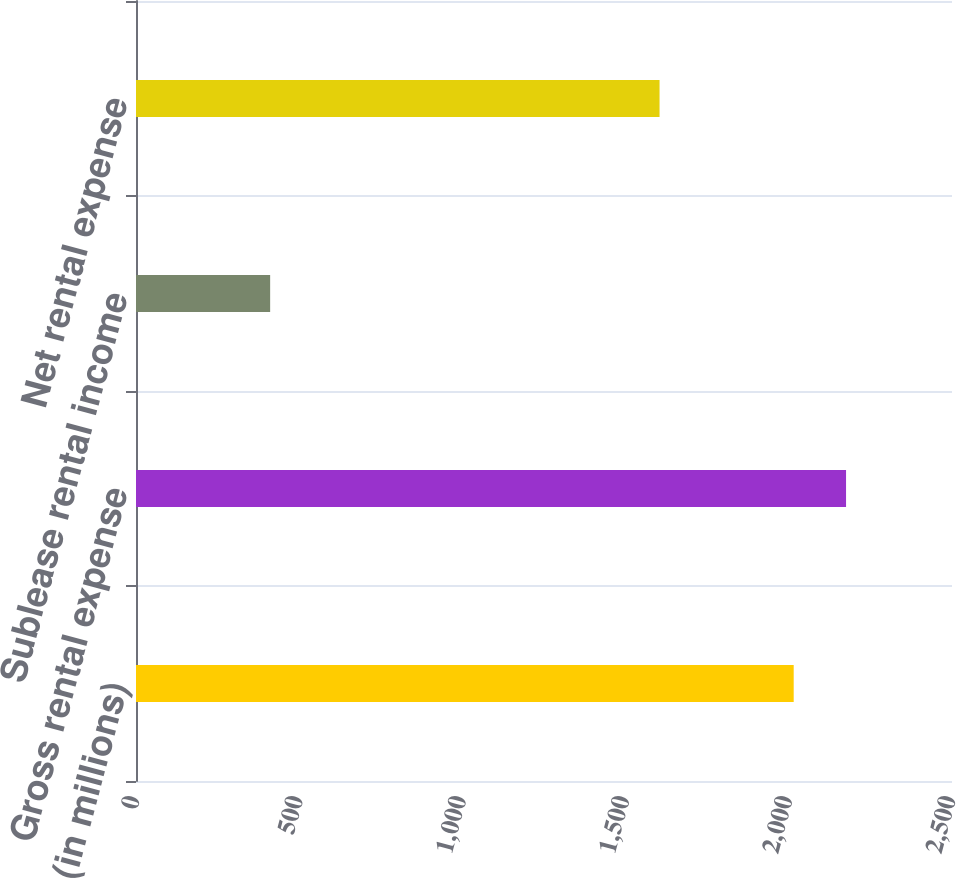<chart> <loc_0><loc_0><loc_500><loc_500><bar_chart><fcel>(in millions)<fcel>Gross rental expense<fcel>Sublease rental income<fcel>Net rental expense<nl><fcel>2015<fcel>2175.4<fcel>411<fcel>1604<nl></chart> 